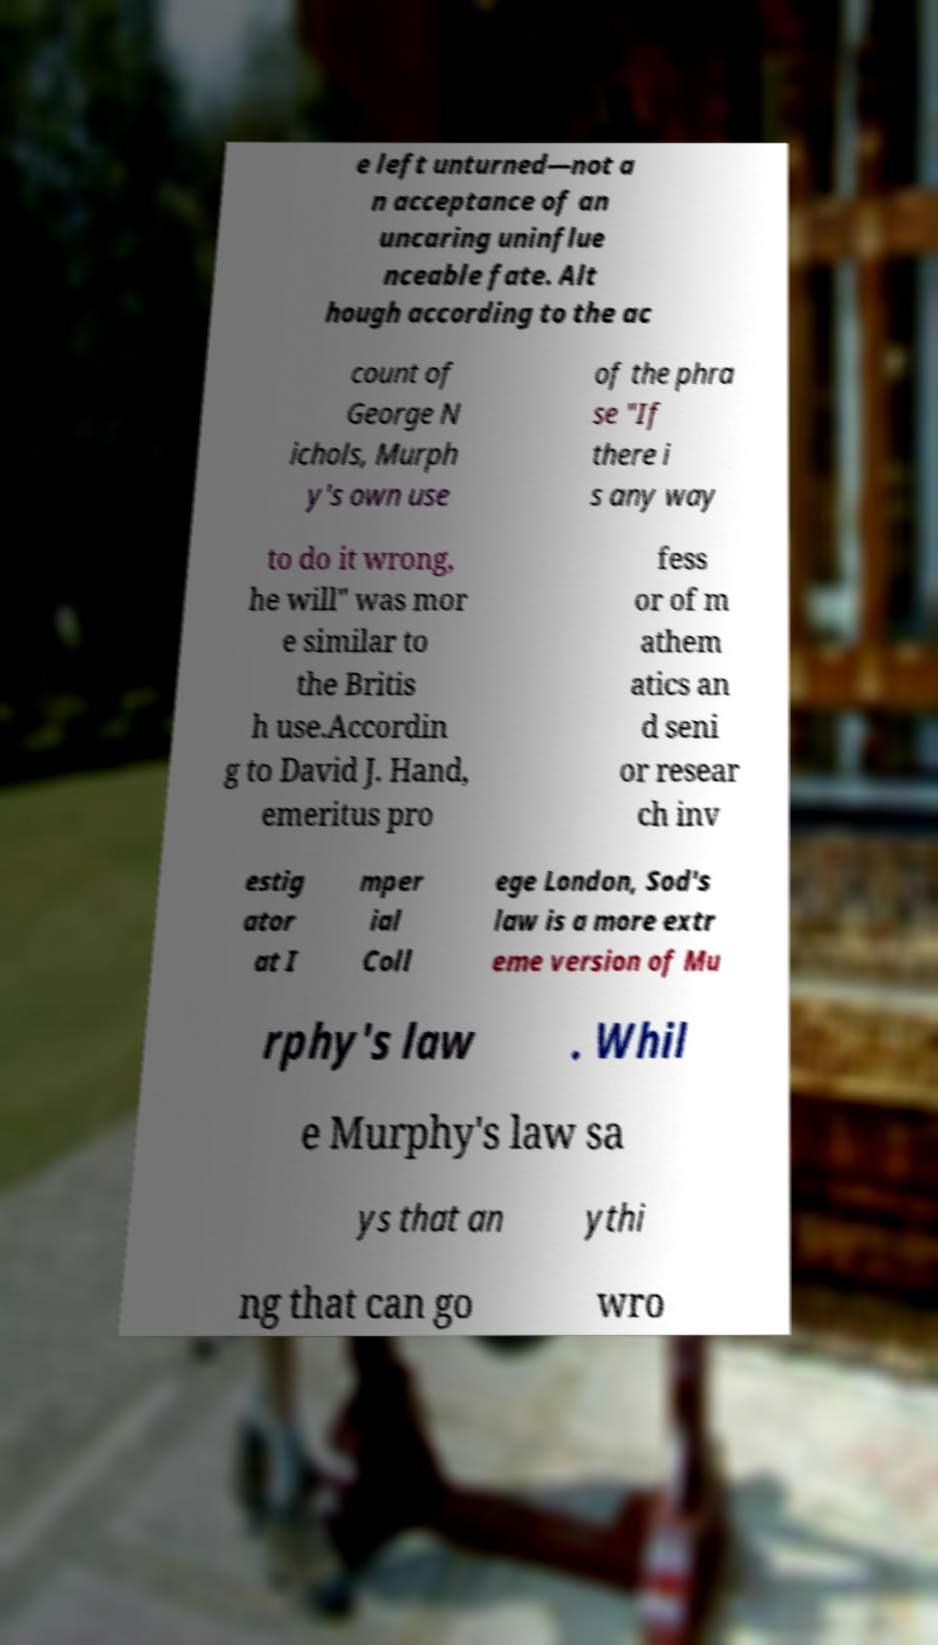Please identify and transcribe the text found in this image. e left unturned—not a n acceptance of an uncaring uninflue nceable fate. Alt hough according to the ac count of George N ichols, Murph y's own use of the phra se "If there i s any way to do it wrong, he will" was mor e similar to the Britis h use.Accordin g to David J. Hand, emeritus pro fess or of m athem atics an d seni or resear ch inv estig ator at I mper ial Coll ege London, Sod's law is a more extr eme version of Mu rphy's law . Whil e Murphy's law sa ys that an ythi ng that can go wro 